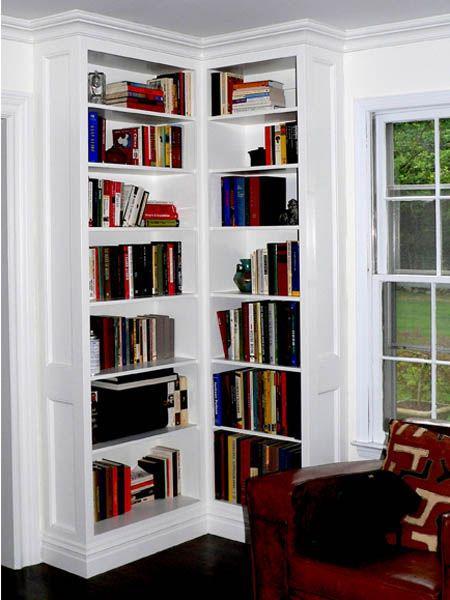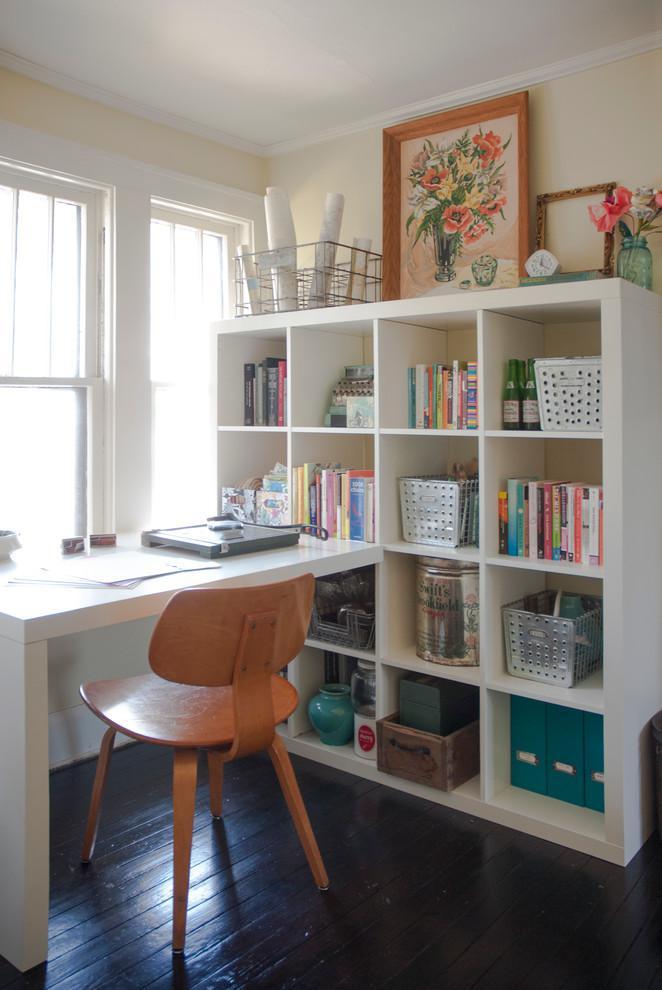The first image is the image on the left, the second image is the image on the right. Examine the images to the left and right. Is the description "One image shows a completely empty white shelf while the other shows a shelf with contents, and all shelves are designed to fit in a corner." accurate? Answer yes or no. No. The first image is the image on the left, the second image is the image on the right. Analyze the images presented: Is the assertion "A shelf unit consists of two tall, narrow shelves of equal size, placed at ninety degree angles to each other in the corner of a room." valid? Answer yes or no. Yes. 